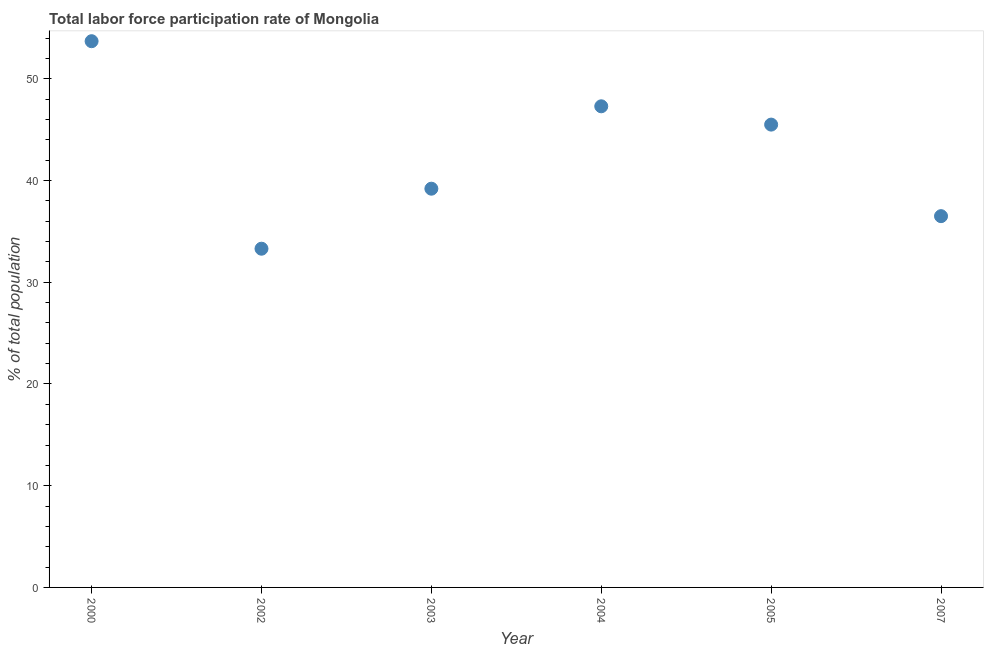What is the total labor force participation rate in 2002?
Offer a terse response. 33.3. Across all years, what is the maximum total labor force participation rate?
Your answer should be compact. 53.7. Across all years, what is the minimum total labor force participation rate?
Your answer should be very brief. 33.3. In which year was the total labor force participation rate maximum?
Provide a short and direct response. 2000. In which year was the total labor force participation rate minimum?
Ensure brevity in your answer.  2002. What is the sum of the total labor force participation rate?
Your answer should be compact. 255.5. What is the difference between the total labor force participation rate in 2003 and 2005?
Provide a succinct answer. -6.3. What is the average total labor force participation rate per year?
Your answer should be very brief. 42.58. What is the median total labor force participation rate?
Make the answer very short. 42.35. In how many years, is the total labor force participation rate greater than 22 %?
Give a very brief answer. 6. Do a majority of the years between 2007 and 2005 (inclusive) have total labor force participation rate greater than 6 %?
Make the answer very short. No. What is the ratio of the total labor force participation rate in 2002 to that in 2007?
Your response must be concise. 0.91. What is the difference between the highest and the second highest total labor force participation rate?
Your answer should be very brief. 6.4. What is the difference between the highest and the lowest total labor force participation rate?
Offer a very short reply. 20.4. In how many years, is the total labor force participation rate greater than the average total labor force participation rate taken over all years?
Your response must be concise. 3. What is the difference between two consecutive major ticks on the Y-axis?
Your response must be concise. 10. What is the title of the graph?
Keep it short and to the point. Total labor force participation rate of Mongolia. What is the label or title of the Y-axis?
Ensure brevity in your answer.  % of total population. What is the % of total population in 2000?
Provide a short and direct response. 53.7. What is the % of total population in 2002?
Offer a very short reply. 33.3. What is the % of total population in 2003?
Provide a short and direct response. 39.2. What is the % of total population in 2004?
Give a very brief answer. 47.3. What is the % of total population in 2005?
Offer a terse response. 45.5. What is the % of total population in 2007?
Make the answer very short. 36.5. What is the difference between the % of total population in 2000 and 2002?
Make the answer very short. 20.4. What is the difference between the % of total population in 2000 and 2003?
Keep it short and to the point. 14.5. What is the difference between the % of total population in 2000 and 2007?
Ensure brevity in your answer.  17.2. What is the difference between the % of total population in 2002 and 2003?
Offer a terse response. -5.9. What is the difference between the % of total population in 2002 and 2004?
Give a very brief answer. -14. What is the difference between the % of total population in 2002 and 2005?
Keep it short and to the point. -12.2. What is the difference between the % of total population in 2003 and 2005?
Keep it short and to the point. -6.3. What is the difference between the % of total population in 2003 and 2007?
Make the answer very short. 2.7. What is the difference between the % of total population in 2004 and 2007?
Provide a short and direct response. 10.8. What is the difference between the % of total population in 2005 and 2007?
Your answer should be compact. 9. What is the ratio of the % of total population in 2000 to that in 2002?
Keep it short and to the point. 1.61. What is the ratio of the % of total population in 2000 to that in 2003?
Ensure brevity in your answer.  1.37. What is the ratio of the % of total population in 2000 to that in 2004?
Your answer should be compact. 1.14. What is the ratio of the % of total population in 2000 to that in 2005?
Provide a succinct answer. 1.18. What is the ratio of the % of total population in 2000 to that in 2007?
Your answer should be very brief. 1.47. What is the ratio of the % of total population in 2002 to that in 2003?
Make the answer very short. 0.85. What is the ratio of the % of total population in 2002 to that in 2004?
Your response must be concise. 0.7. What is the ratio of the % of total population in 2002 to that in 2005?
Give a very brief answer. 0.73. What is the ratio of the % of total population in 2002 to that in 2007?
Give a very brief answer. 0.91. What is the ratio of the % of total population in 2003 to that in 2004?
Offer a very short reply. 0.83. What is the ratio of the % of total population in 2003 to that in 2005?
Provide a short and direct response. 0.86. What is the ratio of the % of total population in 2003 to that in 2007?
Offer a very short reply. 1.07. What is the ratio of the % of total population in 2004 to that in 2005?
Your response must be concise. 1.04. What is the ratio of the % of total population in 2004 to that in 2007?
Your response must be concise. 1.3. What is the ratio of the % of total population in 2005 to that in 2007?
Your answer should be compact. 1.25. 